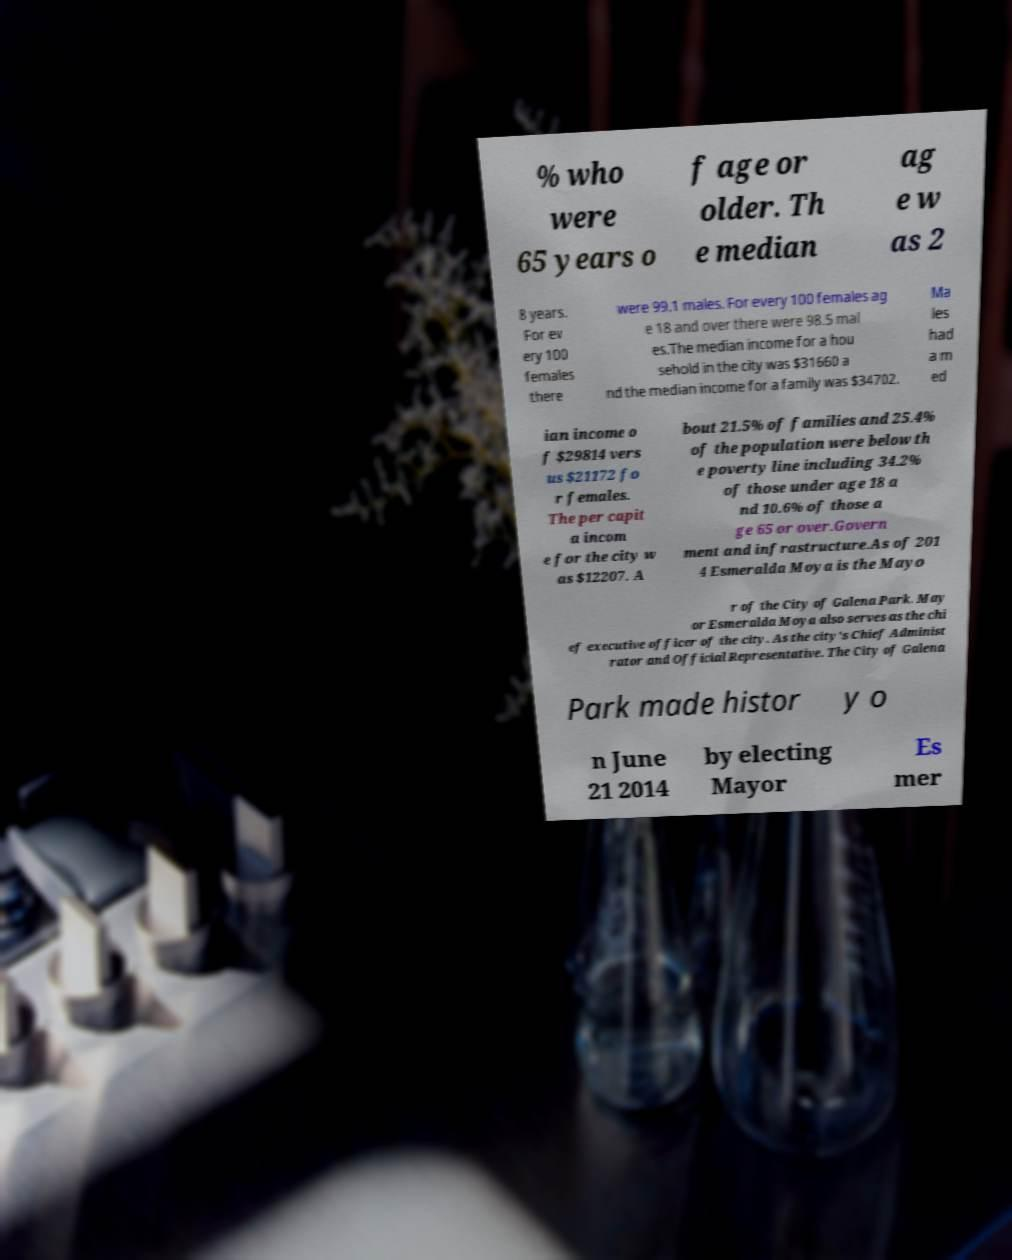Could you assist in decoding the text presented in this image and type it out clearly? % who were 65 years o f age or older. Th e median ag e w as 2 8 years. For ev ery 100 females there were 99.1 males. For every 100 females ag e 18 and over there were 98.5 mal es.The median income for a hou sehold in the city was $31660 a nd the median income for a family was $34702. Ma les had a m ed ian income o f $29814 vers us $21172 fo r females. The per capit a incom e for the city w as $12207. A bout 21.5% of families and 25.4% of the population were below th e poverty line including 34.2% of those under age 18 a nd 10.6% of those a ge 65 or over.Govern ment and infrastructure.As of 201 4 Esmeralda Moya is the Mayo r of the City of Galena Park. May or Esmeralda Moya also serves as the chi ef executive officer of the city. As the city's Chief Administ rator and Official Representative. The City of Galena Park made histor y o n June 21 2014 by electing Mayor Es mer 